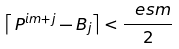<formula> <loc_0><loc_0><loc_500><loc_500>\left \lceil \, P ^ { i m + j } - B _ { j } \right \rceil < \frac { \ e s m } { 2 }</formula> 